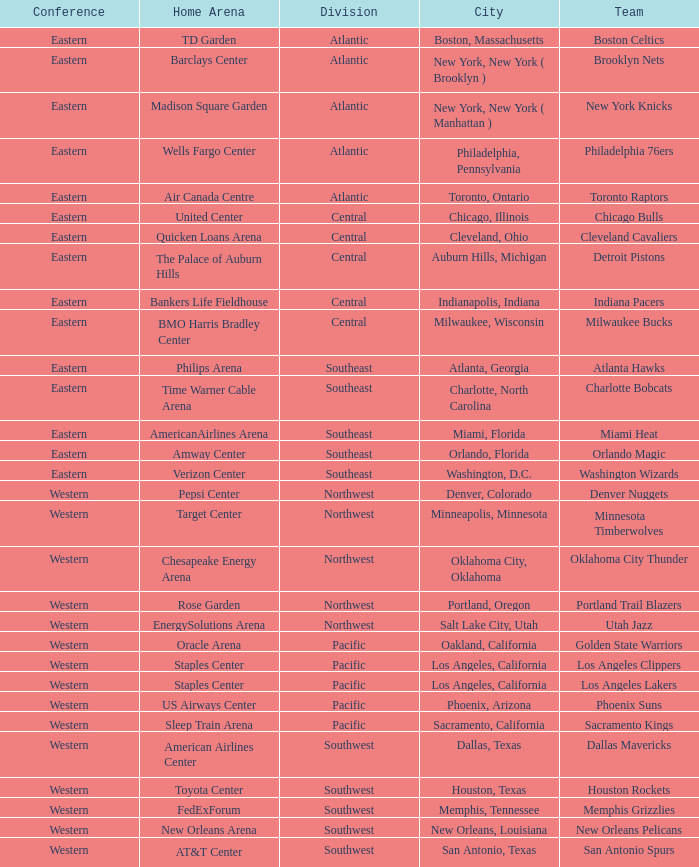Which city includes the Target Center arena? Minneapolis, Minnesota. 